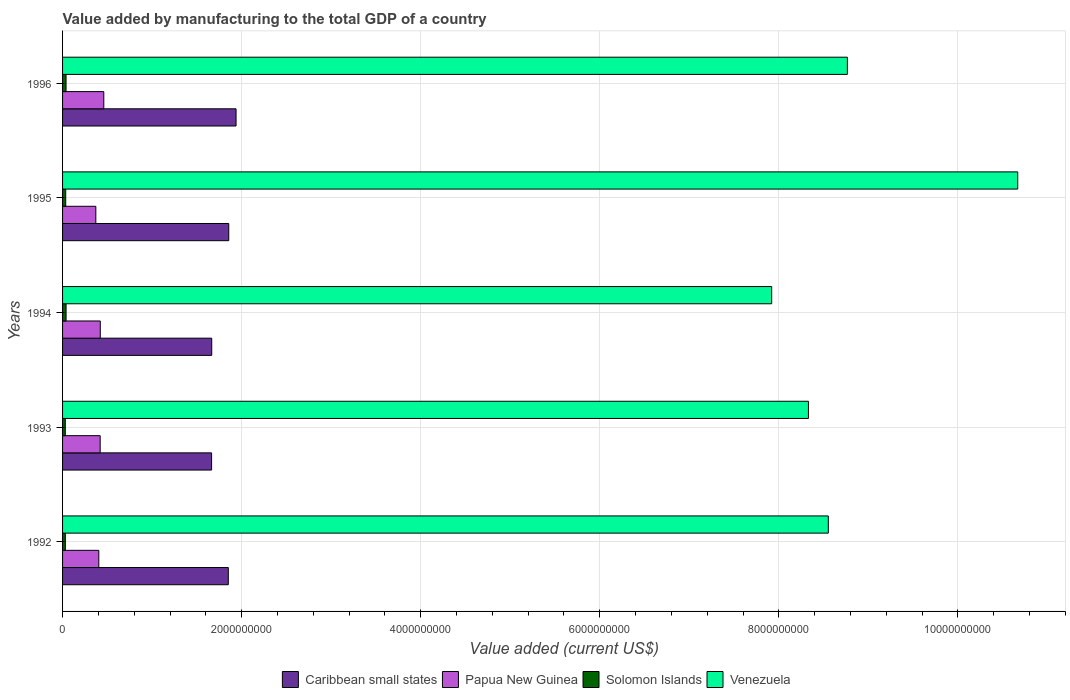How many different coloured bars are there?
Your response must be concise. 4. Are the number of bars per tick equal to the number of legend labels?
Provide a succinct answer. Yes. What is the label of the 1st group of bars from the top?
Provide a short and direct response. 1996. What is the value added by manufacturing to the total GDP in Papua New Guinea in 1996?
Ensure brevity in your answer.  4.61e+08. Across all years, what is the maximum value added by manufacturing to the total GDP in Papua New Guinea?
Offer a terse response. 4.61e+08. Across all years, what is the minimum value added by manufacturing to the total GDP in Venezuela?
Provide a succinct answer. 7.92e+09. What is the total value added by manufacturing to the total GDP in Papua New Guinea in the graph?
Give a very brief answer. 2.08e+09. What is the difference between the value added by manufacturing to the total GDP in Papua New Guinea in 1993 and that in 1995?
Keep it short and to the point. 4.85e+07. What is the difference between the value added by manufacturing to the total GDP in Caribbean small states in 1993 and the value added by manufacturing to the total GDP in Venezuela in 1992?
Ensure brevity in your answer.  -6.89e+09. What is the average value added by manufacturing to the total GDP in Caribbean small states per year?
Ensure brevity in your answer.  1.80e+09. In the year 1993, what is the difference between the value added by manufacturing to the total GDP in Solomon Islands and value added by manufacturing to the total GDP in Papua New Guinea?
Your answer should be compact. -3.90e+08. In how many years, is the value added by manufacturing to the total GDP in Caribbean small states greater than 5600000000 US$?
Give a very brief answer. 0. What is the ratio of the value added by manufacturing to the total GDP in Venezuela in 1994 to that in 1996?
Ensure brevity in your answer.  0.9. What is the difference between the highest and the second highest value added by manufacturing to the total GDP in Venezuela?
Give a very brief answer. 1.90e+09. What is the difference between the highest and the lowest value added by manufacturing to the total GDP in Papua New Guinea?
Your answer should be compact. 8.90e+07. In how many years, is the value added by manufacturing to the total GDP in Solomon Islands greater than the average value added by manufacturing to the total GDP in Solomon Islands taken over all years?
Ensure brevity in your answer.  3. Is it the case that in every year, the sum of the value added by manufacturing to the total GDP in Venezuela and value added by manufacturing to the total GDP in Papua New Guinea is greater than the sum of value added by manufacturing to the total GDP in Caribbean small states and value added by manufacturing to the total GDP in Solomon Islands?
Give a very brief answer. Yes. What does the 3rd bar from the top in 1994 represents?
Offer a terse response. Papua New Guinea. What does the 1st bar from the bottom in 1995 represents?
Your answer should be compact. Caribbean small states. Are all the bars in the graph horizontal?
Your answer should be very brief. Yes. Does the graph contain any zero values?
Give a very brief answer. No. Does the graph contain grids?
Your response must be concise. Yes. How are the legend labels stacked?
Your response must be concise. Horizontal. What is the title of the graph?
Your answer should be compact. Value added by manufacturing to the total GDP of a country. Does "Sub-Saharan Africa (developing only)" appear as one of the legend labels in the graph?
Offer a terse response. No. What is the label or title of the X-axis?
Your answer should be compact. Value added (current US$). What is the label or title of the Y-axis?
Your response must be concise. Years. What is the Value added (current US$) of Caribbean small states in 1992?
Offer a terse response. 1.85e+09. What is the Value added (current US$) of Papua New Guinea in 1992?
Offer a terse response. 4.05e+08. What is the Value added (current US$) of Solomon Islands in 1992?
Your answer should be compact. 3.12e+07. What is the Value added (current US$) of Venezuela in 1992?
Ensure brevity in your answer.  8.55e+09. What is the Value added (current US$) in Caribbean small states in 1993?
Ensure brevity in your answer.  1.66e+09. What is the Value added (current US$) of Papua New Guinea in 1993?
Offer a terse response. 4.20e+08. What is the Value added (current US$) in Solomon Islands in 1993?
Your answer should be compact. 3.04e+07. What is the Value added (current US$) in Venezuela in 1993?
Keep it short and to the point. 8.33e+09. What is the Value added (current US$) in Caribbean small states in 1994?
Your response must be concise. 1.67e+09. What is the Value added (current US$) in Papua New Guinea in 1994?
Your answer should be very brief. 4.21e+08. What is the Value added (current US$) of Solomon Islands in 1994?
Ensure brevity in your answer.  3.92e+07. What is the Value added (current US$) of Venezuela in 1994?
Offer a very short reply. 7.92e+09. What is the Value added (current US$) of Caribbean small states in 1995?
Offer a terse response. 1.86e+09. What is the Value added (current US$) of Papua New Guinea in 1995?
Offer a very short reply. 3.72e+08. What is the Value added (current US$) in Solomon Islands in 1995?
Your answer should be compact. 3.51e+07. What is the Value added (current US$) of Venezuela in 1995?
Provide a short and direct response. 1.07e+1. What is the Value added (current US$) in Caribbean small states in 1996?
Provide a short and direct response. 1.94e+09. What is the Value added (current US$) of Papua New Guinea in 1996?
Provide a short and direct response. 4.61e+08. What is the Value added (current US$) of Solomon Islands in 1996?
Provide a succinct answer. 3.89e+07. What is the Value added (current US$) of Venezuela in 1996?
Give a very brief answer. 8.77e+09. Across all years, what is the maximum Value added (current US$) in Caribbean small states?
Your answer should be compact. 1.94e+09. Across all years, what is the maximum Value added (current US$) in Papua New Guinea?
Offer a very short reply. 4.61e+08. Across all years, what is the maximum Value added (current US$) of Solomon Islands?
Your response must be concise. 3.92e+07. Across all years, what is the maximum Value added (current US$) of Venezuela?
Your response must be concise. 1.07e+1. Across all years, what is the minimum Value added (current US$) in Caribbean small states?
Your response must be concise. 1.66e+09. Across all years, what is the minimum Value added (current US$) in Papua New Guinea?
Give a very brief answer. 3.72e+08. Across all years, what is the minimum Value added (current US$) of Solomon Islands?
Ensure brevity in your answer.  3.04e+07. Across all years, what is the minimum Value added (current US$) in Venezuela?
Provide a succinct answer. 7.92e+09. What is the total Value added (current US$) in Caribbean small states in the graph?
Provide a short and direct response. 8.98e+09. What is the total Value added (current US$) of Papua New Guinea in the graph?
Give a very brief answer. 2.08e+09. What is the total Value added (current US$) in Solomon Islands in the graph?
Your response must be concise. 1.75e+08. What is the total Value added (current US$) of Venezuela in the graph?
Offer a terse response. 4.42e+1. What is the difference between the Value added (current US$) of Caribbean small states in 1992 and that in 1993?
Provide a short and direct response. 1.87e+08. What is the difference between the Value added (current US$) of Papua New Guinea in 1992 and that in 1993?
Your response must be concise. -1.55e+07. What is the difference between the Value added (current US$) in Solomon Islands in 1992 and that in 1993?
Offer a very short reply. 8.82e+05. What is the difference between the Value added (current US$) of Venezuela in 1992 and that in 1993?
Your answer should be compact. 2.22e+08. What is the difference between the Value added (current US$) of Caribbean small states in 1992 and that in 1994?
Your answer should be compact. 1.85e+08. What is the difference between the Value added (current US$) in Papua New Guinea in 1992 and that in 1994?
Ensure brevity in your answer.  -1.66e+07. What is the difference between the Value added (current US$) of Solomon Islands in 1992 and that in 1994?
Offer a terse response. -7.91e+06. What is the difference between the Value added (current US$) in Venezuela in 1992 and that in 1994?
Make the answer very short. 6.32e+08. What is the difference between the Value added (current US$) in Caribbean small states in 1992 and that in 1995?
Your answer should be compact. -4.97e+06. What is the difference between the Value added (current US$) in Papua New Guinea in 1992 and that in 1995?
Provide a short and direct response. 3.30e+07. What is the difference between the Value added (current US$) in Solomon Islands in 1992 and that in 1995?
Ensure brevity in your answer.  -3.90e+06. What is the difference between the Value added (current US$) of Venezuela in 1992 and that in 1995?
Your answer should be very brief. -2.12e+09. What is the difference between the Value added (current US$) in Caribbean small states in 1992 and that in 1996?
Offer a terse response. -8.66e+07. What is the difference between the Value added (current US$) of Papua New Guinea in 1992 and that in 1996?
Provide a short and direct response. -5.59e+07. What is the difference between the Value added (current US$) of Solomon Islands in 1992 and that in 1996?
Provide a short and direct response. -7.61e+06. What is the difference between the Value added (current US$) in Venezuela in 1992 and that in 1996?
Your answer should be compact. -2.13e+08. What is the difference between the Value added (current US$) of Caribbean small states in 1993 and that in 1994?
Offer a very short reply. -1.61e+06. What is the difference between the Value added (current US$) in Papua New Guinea in 1993 and that in 1994?
Your answer should be very brief. -1.10e+06. What is the difference between the Value added (current US$) in Solomon Islands in 1993 and that in 1994?
Your answer should be compact. -8.80e+06. What is the difference between the Value added (current US$) of Venezuela in 1993 and that in 1994?
Ensure brevity in your answer.  4.10e+08. What is the difference between the Value added (current US$) of Caribbean small states in 1993 and that in 1995?
Offer a terse response. -1.92e+08. What is the difference between the Value added (current US$) in Papua New Guinea in 1993 and that in 1995?
Keep it short and to the point. 4.85e+07. What is the difference between the Value added (current US$) of Solomon Islands in 1993 and that in 1995?
Ensure brevity in your answer.  -4.78e+06. What is the difference between the Value added (current US$) of Venezuela in 1993 and that in 1995?
Ensure brevity in your answer.  -2.34e+09. What is the difference between the Value added (current US$) of Caribbean small states in 1993 and that in 1996?
Keep it short and to the point. -2.73e+08. What is the difference between the Value added (current US$) in Papua New Guinea in 1993 and that in 1996?
Give a very brief answer. -4.05e+07. What is the difference between the Value added (current US$) of Solomon Islands in 1993 and that in 1996?
Ensure brevity in your answer.  -8.50e+06. What is the difference between the Value added (current US$) of Venezuela in 1993 and that in 1996?
Offer a very short reply. -4.35e+08. What is the difference between the Value added (current US$) in Caribbean small states in 1994 and that in 1995?
Your answer should be very brief. -1.90e+08. What is the difference between the Value added (current US$) of Papua New Guinea in 1994 and that in 1995?
Offer a very short reply. 4.96e+07. What is the difference between the Value added (current US$) in Solomon Islands in 1994 and that in 1995?
Your answer should be very brief. 4.02e+06. What is the difference between the Value added (current US$) in Venezuela in 1994 and that in 1995?
Keep it short and to the point. -2.75e+09. What is the difference between the Value added (current US$) of Caribbean small states in 1994 and that in 1996?
Provide a short and direct response. -2.72e+08. What is the difference between the Value added (current US$) of Papua New Guinea in 1994 and that in 1996?
Provide a succinct answer. -3.94e+07. What is the difference between the Value added (current US$) in Solomon Islands in 1994 and that in 1996?
Provide a succinct answer. 3.00e+05. What is the difference between the Value added (current US$) of Venezuela in 1994 and that in 1996?
Offer a very short reply. -8.45e+08. What is the difference between the Value added (current US$) of Caribbean small states in 1995 and that in 1996?
Offer a terse response. -8.16e+07. What is the difference between the Value added (current US$) of Papua New Guinea in 1995 and that in 1996?
Give a very brief answer. -8.90e+07. What is the difference between the Value added (current US$) of Solomon Islands in 1995 and that in 1996?
Provide a succinct answer. -3.72e+06. What is the difference between the Value added (current US$) of Venezuela in 1995 and that in 1996?
Offer a terse response. 1.90e+09. What is the difference between the Value added (current US$) in Caribbean small states in 1992 and the Value added (current US$) in Papua New Guinea in 1993?
Provide a succinct answer. 1.43e+09. What is the difference between the Value added (current US$) in Caribbean small states in 1992 and the Value added (current US$) in Solomon Islands in 1993?
Offer a very short reply. 1.82e+09. What is the difference between the Value added (current US$) in Caribbean small states in 1992 and the Value added (current US$) in Venezuela in 1993?
Provide a succinct answer. -6.48e+09. What is the difference between the Value added (current US$) in Papua New Guinea in 1992 and the Value added (current US$) in Solomon Islands in 1993?
Your answer should be compact. 3.74e+08. What is the difference between the Value added (current US$) of Papua New Guinea in 1992 and the Value added (current US$) of Venezuela in 1993?
Offer a very short reply. -7.93e+09. What is the difference between the Value added (current US$) in Solomon Islands in 1992 and the Value added (current US$) in Venezuela in 1993?
Provide a short and direct response. -8.30e+09. What is the difference between the Value added (current US$) of Caribbean small states in 1992 and the Value added (current US$) of Papua New Guinea in 1994?
Give a very brief answer. 1.43e+09. What is the difference between the Value added (current US$) in Caribbean small states in 1992 and the Value added (current US$) in Solomon Islands in 1994?
Make the answer very short. 1.81e+09. What is the difference between the Value added (current US$) of Caribbean small states in 1992 and the Value added (current US$) of Venezuela in 1994?
Make the answer very short. -6.07e+09. What is the difference between the Value added (current US$) in Papua New Guinea in 1992 and the Value added (current US$) in Solomon Islands in 1994?
Your answer should be very brief. 3.65e+08. What is the difference between the Value added (current US$) of Papua New Guinea in 1992 and the Value added (current US$) of Venezuela in 1994?
Give a very brief answer. -7.52e+09. What is the difference between the Value added (current US$) of Solomon Islands in 1992 and the Value added (current US$) of Venezuela in 1994?
Provide a short and direct response. -7.89e+09. What is the difference between the Value added (current US$) of Caribbean small states in 1992 and the Value added (current US$) of Papua New Guinea in 1995?
Give a very brief answer. 1.48e+09. What is the difference between the Value added (current US$) of Caribbean small states in 1992 and the Value added (current US$) of Solomon Islands in 1995?
Keep it short and to the point. 1.82e+09. What is the difference between the Value added (current US$) of Caribbean small states in 1992 and the Value added (current US$) of Venezuela in 1995?
Make the answer very short. -8.82e+09. What is the difference between the Value added (current US$) of Papua New Guinea in 1992 and the Value added (current US$) of Solomon Islands in 1995?
Your answer should be very brief. 3.69e+08. What is the difference between the Value added (current US$) of Papua New Guinea in 1992 and the Value added (current US$) of Venezuela in 1995?
Keep it short and to the point. -1.03e+1. What is the difference between the Value added (current US$) in Solomon Islands in 1992 and the Value added (current US$) in Venezuela in 1995?
Your response must be concise. -1.06e+1. What is the difference between the Value added (current US$) of Caribbean small states in 1992 and the Value added (current US$) of Papua New Guinea in 1996?
Give a very brief answer. 1.39e+09. What is the difference between the Value added (current US$) of Caribbean small states in 1992 and the Value added (current US$) of Solomon Islands in 1996?
Ensure brevity in your answer.  1.81e+09. What is the difference between the Value added (current US$) in Caribbean small states in 1992 and the Value added (current US$) in Venezuela in 1996?
Offer a terse response. -6.91e+09. What is the difference between the Value added (current US$) in Papua New Guinea in 1992 and the Value added (current US$) in Solomon Islands in 1996?
Provide a succinct answer. 3.66e+08. What is the difference between the Value added (current US$) of Papua New Guinea in 1992 and the Value added (current US$) of Venezuela in 1996?
Make the answer very short. -8.36e+09. What is the difference between the Value added (current US$) of Solomon Islands in 1992 and the Value added (current US$) of Venezuela in 1996?
Offer a terse response. -8.73e+09. What is the difference between the Value added (current US$) in Caribbean small states in 1993 and the Value added (current US$) in Papua New Guinea in 1994?
Provide a succinct answer. 1.24e+09. What is the difference between the Value added (current US$) in Caribbean small states in 1993 and the Value added (current US$) in Solomon Islands in 1994?
Keep it short and to the point. 1.63e+09. What is the difference between the Value added (current US$) in Caribbean small states in 1993 and the Value added (current US$) in Venezuela in 1994?
Provide a short and direct response. -6.26e+09. What is the difference between the Value added (current US$) of Papua New Guinea in 1993 and the Value added (current US$) of Solomon Islands in 1994?
Your answer should be compact. 3.81e+08. What is the difference between the Value added (current US$) of Papua New Guinea in 1993 and the Value added (current US$) of Venezuela in 1994?
Your answer should be compact. -7.50e+09. What is the difference between the Value added (current US$) of Solomon Islands in 1993 and the Value added (current US$) of Venezuela in 1994?
Your answer should be very brief. -7.89e+09. What is the difference between the Value added (current US$) in Caribbean small states in 1993 and the Value added (current US$) in Papua New Guinea in 1995?
Offer a terse response. 1.29e+09. What is the difference between the Value added (current US$) of Caribbean small states in 1993 and the Value added (current US$) of Solomon Islands in 1995?
Give a very brief answer. 1.63e+09. What is the difference between the Value added (current US$) of Caribbean small states in 1993 and the Value added (current US$) of Venezuela in 1995?
Offer a very short reply. -9.00e+09. What is the difference between the Value added (current US$) in Papua New Guinea in 1993 and the Value added (current US$) in Solomon Islands in 1995?
Ensure brevity in your answer.  3.85e+08. What is the difference between the Value added (current US$) of Papua New Guinea in 1993 and the Value added (current US$) of Venezuela in 1995?
Make the answer very short. -1.02e+1. What is the difference between the Value added (current US$) of Solomon Islands in 1993 and the Value added (current US$) of Venezuela in 1995?
Your answer should be compact. -1.06e+1. What is the difference between the Value added (current US$) of Caribbean small states in 1993 and the Value added (current US$) of Papua New Guinea in 1996?
Provide a succinct answer. 1.20e+09. What is the difference between the Value added (current US$) in Caribbean small states in 1993 and the Value added (current US$) in Solomon Islands in 1996?
Provide a short and direct response. 1.63e+09. What is the difference between the Value added (current US$) in Caribbean small states in 1993 and the Value added (current US$) in Venezuela in 1996?
Keep it short and to the point. -7.10e+09. What is the difference between the Value added (current US$) in Papua New Guinea in 1993 and the Value added (current US$) in Solomon Islands in 1996?
Offer a very short reply. 3.81e+08. What is the difference between the Value added (current US$) of Papua New Guinea in 1993 and the Value added (current US$) of Venezuela in 1996?
Provide a succinct answer. -8.35e+09. What is the difference between the Value added (current US$) of Solomon Islands in 1993 and the Value added (current US$) of Venezuela in 1996?
Offer a terse response. -8.74e+09. What is the difference between the Value added (current US$) in Caribbean small states in 1994 and the Value added (current US$) in Papua New Guinea in 1995?
Your answer should be compact. 1.29e+09. What is the difference between the Value added (current US$) in Caribbean small states in 1994 and the Value added (current US$) in Solomon Islands in 1995?
Provide a succinct answer. 1.63e+09. What is the difference between the Value added (current US$) of Caribbean small states in 1994 and the Value added (current US$) of Venezuela in 1995?
Give a very brief answer. -9.00e+09. What is the difference between the Value added (current US$) in Papua New Guinea in 1994 and the Value added (current US$) in Solomon Islands in 1995?
Keep it short and to the point. 3.86e+08. What is the difference between the Value added (current US$) of Papua New Guinea in 1994 and the Value added (current US$) of Venezuela in 1995?
Provide a succinct answer. -1.02e+1. What is the difference between the Value added (current US$) of Solomon Islands in 1994 and the Value added (current US$) of Venezuela in 1995?
Keep it short and to the point. -1.06e+1. What is the difference between the Value added (current US$) in Caribbean small states in 1994 and the Value added (current US$) in Papua New Guinea in 1996?
Your response must be concise. 1.21e+09. What is the difference between the Value added (current US$) of Caribbean small states in 1994 and the Value added (current US$) of Solomon Islands in 1996?
Provide a succinct answer. 1.63e+09. What is the difference between the Value added (current US$) of Caribbean small states in 1994 and the Value added (current US$) of Venezuela in 1996?
Provide a succinct answer. -7.10e+09. What is the difference between the Value added (current US$) of Papua New Guinea in 1994 and the Value added (current US$) of Solomon Islands in 1996?
Provide a succinct answer. 3.82e+08. What is the difference between the Value added (current US$) of Papua New Guinea in 1994 and the Value added (current US$) of Venezuela in 1996?
Your answer should be very brief. -8.34e+09. What is the difference between the Value added (current US$) of Solomon Islands in 1994 and the Value added (current US$) of Venezuela in 1996?
Ensure brevity in your answer.  -8.73e+09. What is the difference between the Value added (current US$) in Caribbean small states in 1995 and the Value added (current US$) in Papua New Guinea in 1996?
Ensure brevity in your answer.  1.40e+09. What is the difference between the Value added (current US$) in Caribbean small states in 1995 and the Value added (current US$) in Solomon Islands in 1996?
Give a very brief answer. 1.82e+09. What is the difference between the Value added (current US$) in Caribbean small states in 1995 and the Value added (current US$) in Venezuela in 1996?
Keep it short and to the point. -6.91e+09. What is the difference between the Value added (current US$) of Papua New Guinea in 1995 and the Value added (current US$) of Solomon Islands in 1996?
Provide a succinct answer. 3.33e+08. What is the difference between the Value added (current US$) in Papua New Guinea in 1995 and the Value added (current US$) in Venezuela in 1996?
Offer a very short reply. -8.39e+09. What is the difference between the Value added (current US$) of Solomon Islands in 1995 and the Value added (current US$) of Venezuela in 1996?
Offer a very short reply. -8.73e+09. What is the average Value added (current US$) in Caribbean small states per year?
Offer a terse response. 1.80e+09. What is the average Value added (current US$) in Papua New Guinea per year?
Provide a short and direct response. 4.16e+08. What is the average Value added (current US$) of Solomon Islands per year?
Ensure brevity in your answer.  3.50e+07. What is the average Value added (current US$) in Venezuela per year?
Ensure brevity in your answer.  8.85e+09. In the year 1992, what is the difference between the Value added (current US$) of Caribbean small states and Value added (current US$) of Papua New Guinea?
Make the answer very short. 1.45e+09. In the year 1992, what is the difference between the Value added (current US$) in Caribbean small states and Value added (current US$) in Solomon Islands?
Your answer should be very brief. 1.82e+09. In the year 1992, what is the difference between the Value added (current US$) of Caribbean small states and Value added (current US$) of Venezuela?
Provide a succinct answer. -6.70e+09. In the year 1992, what is the difference between the Value added (current US$) in Papua New Guinea and Value added (current US$) in Solomon Islands?
Provide a short and direct response. 3.73e+08. In the year 1992, what is the difference between the Value added (current US$) of Papua New Guinea and Value added (current US$) of Venezuela?
Make the answer very short. -8.15e+09. In the year 1992, what is the difference between the Value added (current US$) of Solomon Islands and Value added (current US$) of Venezuela?
Your answer should be compact. -8.52e+09. In the year 1993, what is the difference between the Value added (current US$) of Caribbean small states and Value added (current US$) of Papua New Guinea?
Keep it short and to the point. 1.24e+09. In the year 1993, what is the difference between the Value added (current US$) of Caribbean small states and Value added (current US$) of Solomon Islands?
Your answer should be very brief. 1.63e+09. In the year 1993, what is the difference between the Value added (current US$) in Caribbean small states and Value added (current US$) in Venezuela?
Your response must be concise. -6.67e+09. In the year 1993, what is the difference between the Value added (current US$) in Papua New Guinea and Value added (current US$) in Solomon Islands?
Keep it short and to the point. 3.90e+08. In the year 1993, what is the difference between the Value added (current US$) in Papua New Guinea and Value added (current US$) in Venezuela?
Your response must be concise. -7.91e+09. In the year 1993, what is the difference between the Value added (current US$) in Solomon Islands and Value added (current US$) in Venezuela?
Give a very brief answer. -8.30e+09. In the year 1994, what is the difference between the Value added (current US$) in Caribbean small states and Value added (current US$) in Papua New Guinea?
Your answer should be very brief. 1.24e+09. In the year 1994, what is the difference between the Value added (current US$) of Caribbean small states and Value added (current US$) of Solomon Islands?
Your answer should be very brief. 1.63e+09. In the year 1994, what is the difference between the Value added (current US$) in Caribbean small states and Value added (current US$) in Venezuela?
Give a very brief answer. -6.25e+09. In the year 1994, what is the difference between the Value added (current US$) of Papua New Guinea and Value added (current US$) of Solomon Islands?
Your answer should be compact. 3.82e+08. In the year 1994, what is the difference between the Value added (current US$) in Papua New Guinea and Value added (current US$) in Venezuela?
Offer a very short reply. -7.50e+09. In the year 1994, what is the difference between the Value added (current US$) in Solomon Islands and Value added (current US$) in Venezuela?
Your answer should be very brief. -7.88e+09. In the year 1995, what is the difference between the Value added (current US$) in Caribbean small states and Value added (current US$) in Papua New Guinea?
Offer a very short reply. 1.48e+09. In the year 1995, what is the difference between the Value added (current US$) in Caribbean small states and Value added (current US$) in Solomon Islands?
Provide a short and direct response. 1.82e+09. In the year 1995, what is the difference between the Value added (current US$) of Caribbean small states and Value added (current US$) of Venezuela?
Make the answer very short. -8.81e+09. In the year 1995, what is the difference between the Value added (current US$) of Papua New Guinea and Value added (current US$) of Solomon Islands?
Your answer should be very brief. 3.36e+08. In the year 1995, what is the difference between the Value added (current US$) of Papua New Guinea and Value added (current US$) of Venezuela?
Make the answer very short. -1.03e+1. In the year 1995, what is the difference between the Value added (current US$) in Solomon Islands and Value added (current US$) in Venezuela?
Make the answer very short. -1.06e+1. In the year 1996, what is the difference between the Value added (current US$) of Caribbean small states and Value added (current US$) of Papua New Guinea?
Offer a very short reply. 1.48e+09. In the year 1996, what is the difference between the Value added (current US$) in Caribbean small states and Value added (current US$) in Solomon Islands?
Your response must be concise. 1.90e+09. In the year 1996, what is the difference between the Value added (current US$) in Caribbean small states and Value added (current US$) in Venezuela?
Your answer should be very brief. -6.83e+09. In the year 1996, what is the difference between the Value added (current US$) in Papua New Guinea and Value added (current US$) in Solomon Islands?
Ensure brevity in your answer.  4.22e+08. In the year 1996, what is the difference between the Value added (current US$) of Papua New Guinea and Value added (current US$) of Venezuela?
Keep it short and to the point. -8.31e+09. In the year 1996, what is the difference between the Value added (current US$) of Solomon Islands and Value added (current US$) of Venezuela?
Your answer should be compact. -8.73e+09. What is the ratio of the Value added (current US$) in Caribbean small states in 1992 to that in 1993?
Give a very brief answer. 1.11. What is the ratio of the Value added (current US$) in Papua New Guinea in 1992 to that in 1993?
Keep it short and to the point. 0.96. What is the ratio of the Value added (current US$) of Solomon Islands in 1992 to that in 1993?
Offer a terse response. 1.03. What is the ratio of the Value added (current US$) of Venezuela in 1992 to that in 1993?
Your answer should be very brief. 1.03. What is the ratio of the Value added (current US$) of Caribbean small states in 1992 to that in 1994?
Your answer should be very brief. 1.11. What is the ratio of the Value added (current US$) in Papua New Guinea in 1992 to that in 1994?
Offer a terse response. 0.96. What is the ratio of the Value added (current US$) in Solomon Islands in 1992 to that in 1994?
Offer a very short reply. 0.8. What is the ratio of the Value added (current US$) in Venezuela in 1992 to that in 1994?
Offer a terse response. 1.08. What is the ratio of the Value added (current US$) in Papua New Guinea in 1992 to that in 1995?
Your answer should be compact. 1.09. What is the ratio of the Value added (current US$) of Solomon Islands in 1992 to that in 1995?
Make the answer very short. 0.89. What is the ratio of the Value added (current US$) in Venezuela in 1992 to that in 1995?
Your answer should be very brief. 0.8. What is the ratio of the Value added (current US$) in Caribbean small states in 1992 to that in 1996?
Your answer should be compact. 0.96. What is the ratio of the Value added (current US$) in Papua New Guinea in 1992 to that in 1996?
Give a very brief answer. 0.88. What is the ratio of the Value added (current US$) in Solomon Islands in 1992 to that in 1996?
Your response must be concise. 0.8. What is the ratio of the Value added (current US$) of Venezuela in 1992 to that in 1996?
Your answer should be very brief. 0.98. What is the ratio of the Value added (current US$) in Solomon Islands in 1993 to that in 1994?
Offer a very short reply. 0.78. What is the ratio of the Value added (current US$) of Venezuela in 1993 to that in 1994?
Provide a short and direct response. 1.05. What is the ratio of the Value added (current US$) of Caribbean small states in 1993 to that in 1995?
Your answer should be compact. 0.9. What is the ratio of the Value added (current US$) of Papua New Guinea in 1993 to that in 1995?
Your answer should be compact. 1.13. What is the ratio of the Value added (current US$) of Solomon Islands in 1993 to that in 1995?
Keep it short and to the point. 0.86. What is the ratio of the Value added (current US$) in Venezuela in 1993 to that in 1995?
Your response must be concise. 0.78. What is the ratio of the Value added (current US$) in Caribbean small states in 1993 to that in 1996?
Your answer should be very brief. 0.86. What is the ratio of the Value added (current US$) in Papua New Guinea in 1993 to that in 1996?
Give a very brief answer. 0.91. What is the ratio of the Value added (current US$) in Solomon Islands in 1993 to that in 1996?
Provide a short and direct response. 0.78. What is the ratio of the Value added (current US$) in Venezuela in 1993 to that in 1996?
Give a very brief answer. 0.95. What is the ratio of the Value added (current US$) of Caribbean small states in 1994 to that in 1995?
Your answer should be compact. 0.9. What is the ratio of the Value added (current US$) in Papua New Guinea in 1994 to that in 1995?
Keep it short and to the point. 1.13. What is the ratio of the Value added (current US$) in Solomon Islands in 1994 to that in 1995?
Your response must be concise. 1.11. What is the ratio of the Value added (current US$) of Venezuela in 1994 to that in 1995?
Provide a succinct answer. 0.74. What is the ratio of the Value added (current US$) in Caribbean small states in 1994 to that in 1996?
Give a very brief answer. 0.86. What is the ratio of the Value added (current US$) in Papua New Guinea in 1994 to that in 1996?
Ensure brevity in your answer.  0.91. What is the ratio of the Value added (current US$) of Solomon Islands in 1994 to that in 1996?
Your answer should be very brief. 1.01. What is the ratio of the Value added (current US$) in Venezuela in 1994 to that in 1996?
Keep it short and to the point. 0.9. What is the ratio of the Value added (current US$) in Caribbean small states in 1995 to that in 1996?
Give a very brief answer. 0.96. What is the ratio of the Value added (current US$) in Papua New Guinea in 1995 to that in 1996?
Make the answer very short. 0.81. What is the ratio of the Value added (current US$) in Solomon Islands in 1995 to that in 1996?
Your answer should be compact. 0.9. What is the ratio of the Value added (current US$) of Venezuela in 1995 to that in 1996?
Ensure brevity in your answer.  1.22. What is the difference between the highest and the second highest Value added (current US$) of Caribbean small states?
Provide a short and direct response. 8.16e+07. What is the difference between the highest and the second highest Value added (current US$) of Papua New Guinea?
Keep it short and to the point. 3.94e+07. What is the difference between the highest and the second highest Value added (current US$) in Solomon Islands?
Make the answer very short. 3.00e+05. What is the difference between the highest and the second highest Value added (current US$) in Venezuela?
Make the answer very short. 1.90e+09. What is the difference between the highest and the lowest Value added (current US$) of Caribbean small states?
Your answer should be compact. 2.73e+08. What is the difference between the highest and the lowest Value added (current US$) of Papua New Guinea?
Provide a short and direct response. 8.90e+07. What is the difference between the highest and the lowest Value added (current US$) in Solomon Islands?
Keep it short and to the point. 8.80e+06. What is the difference between the highest and the lowest Value added (current US$) of Venezuela?
Provide a succinct answer. 2.75e+09. 